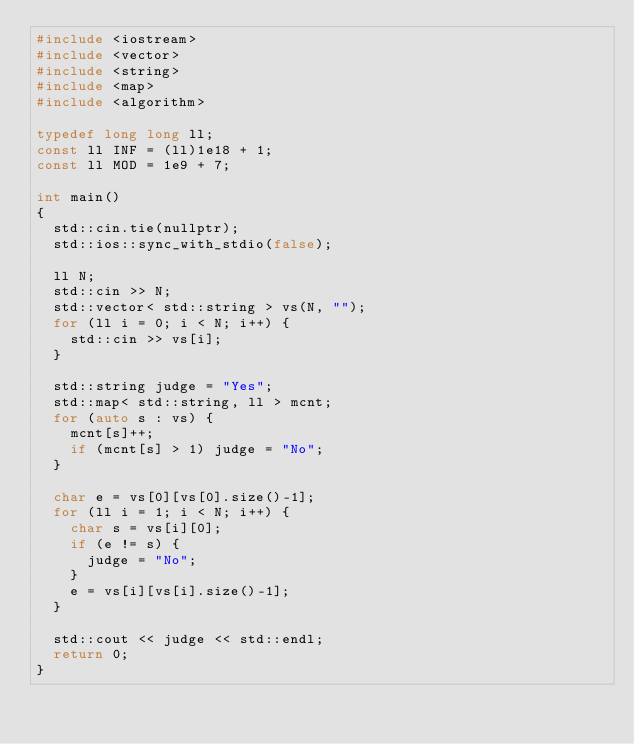Convert code to text. <code><loc_0><loc_0><loc_500><loc_500><_C++_>#include <iostream>
#include <vector>
#include <string>
#include <map>
#include <algorithm>

typedef long long ll;
const ll INF = (ll)1e18 + 1;
const ll MOD = 1e9 + 7;

int main()
{
  std::cin.tie(nullptr);
  std::ios::sync_with_stdio(false);

  ll N;
  std::cin >> N;
  std::vector< std::string > vs(N, "");
  for (ll i = 0; i < N; i++) {
    std::cin >> vs[i];
  }

  std::string judge = "Yes";
  std::map< std::string, ll > mcnt;
  for (auto s : vs) {
    mcnt[s]++;
    if (mcnt[s] > 1) judge = "No";
  }

  char e = vs[0][vs[0].size()-1];
  for (ll i = 1; i < N; i++) {
    char s = vs[i][0];
    if (e != s) {
      judge = "No";
    }
    e = vs[i][vs[i].size()-1];
  }

  std::cout << judge << std::endl;
  return 0;
}
</code> 